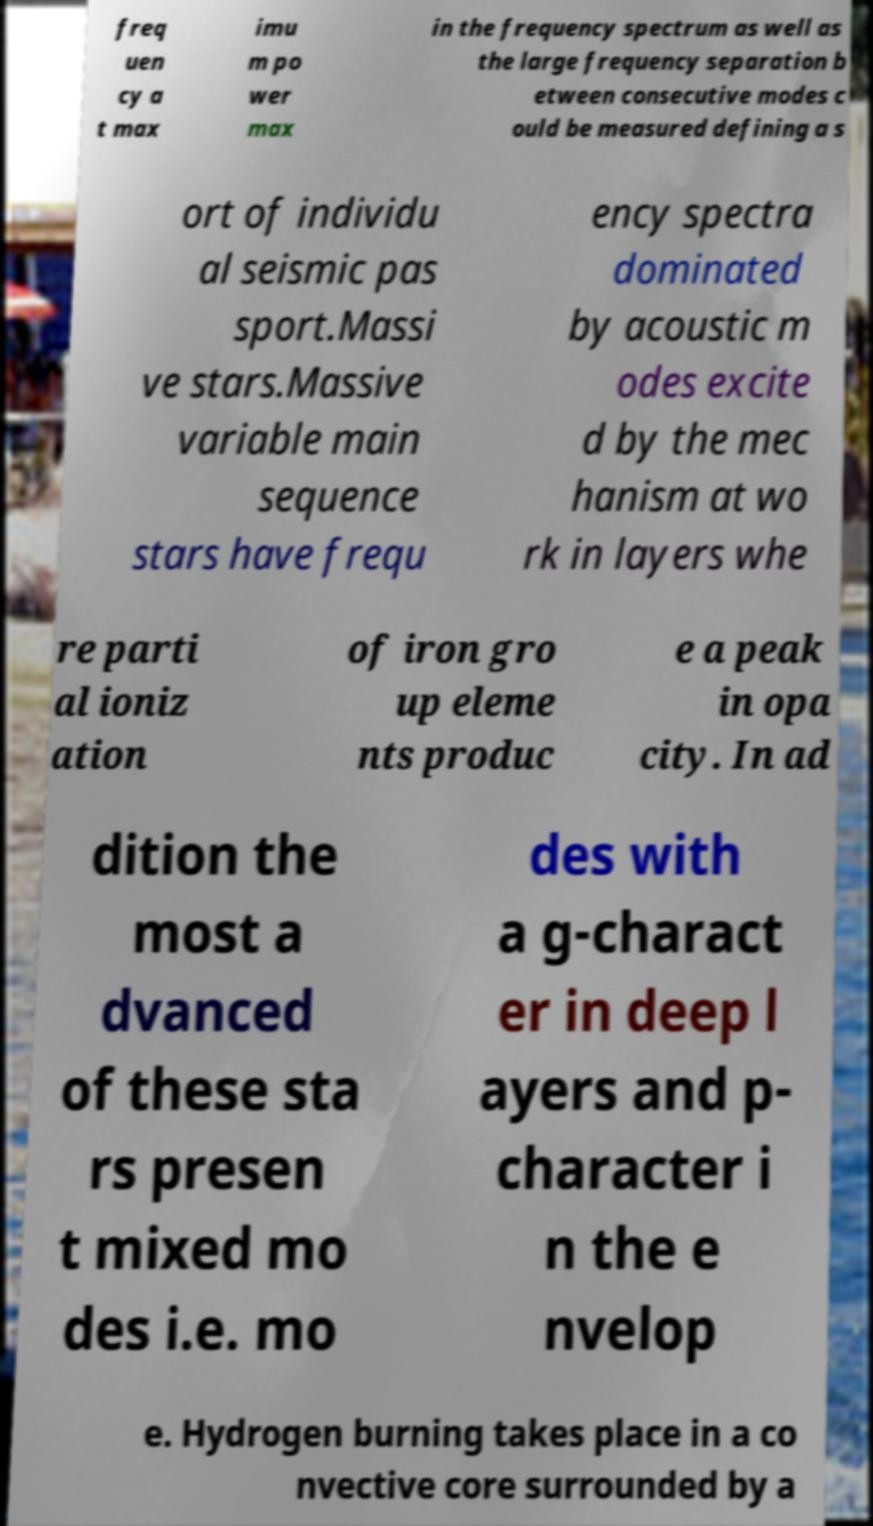Can you read and provide the text displayed in the image?This photo seems to have some interesting text. Can you extract and type it out for me? freq uen cy a t max imu m po wer max in the frequency spectrum as well as the large frequency separation b etween consecutive modes c ould be measured defining a s ort of individu al seismic pas sport.Massi ve stars.Massive variable main sequence stars have frequ ency spectra dominated by acoustic m odes excite d by the mec hanism at wo rk in layers whe re parti al ioniz ation of iron gro up eleme nts produc e a peak in opa city. In ad dition the most a dvanced of these sta rs presen t mixed mo des i.e. mo des with a g-charact er in deep l ayers and p- character i n the e nvelop e. Hydrogen burning takes place in a co nvective core surrounded by a 